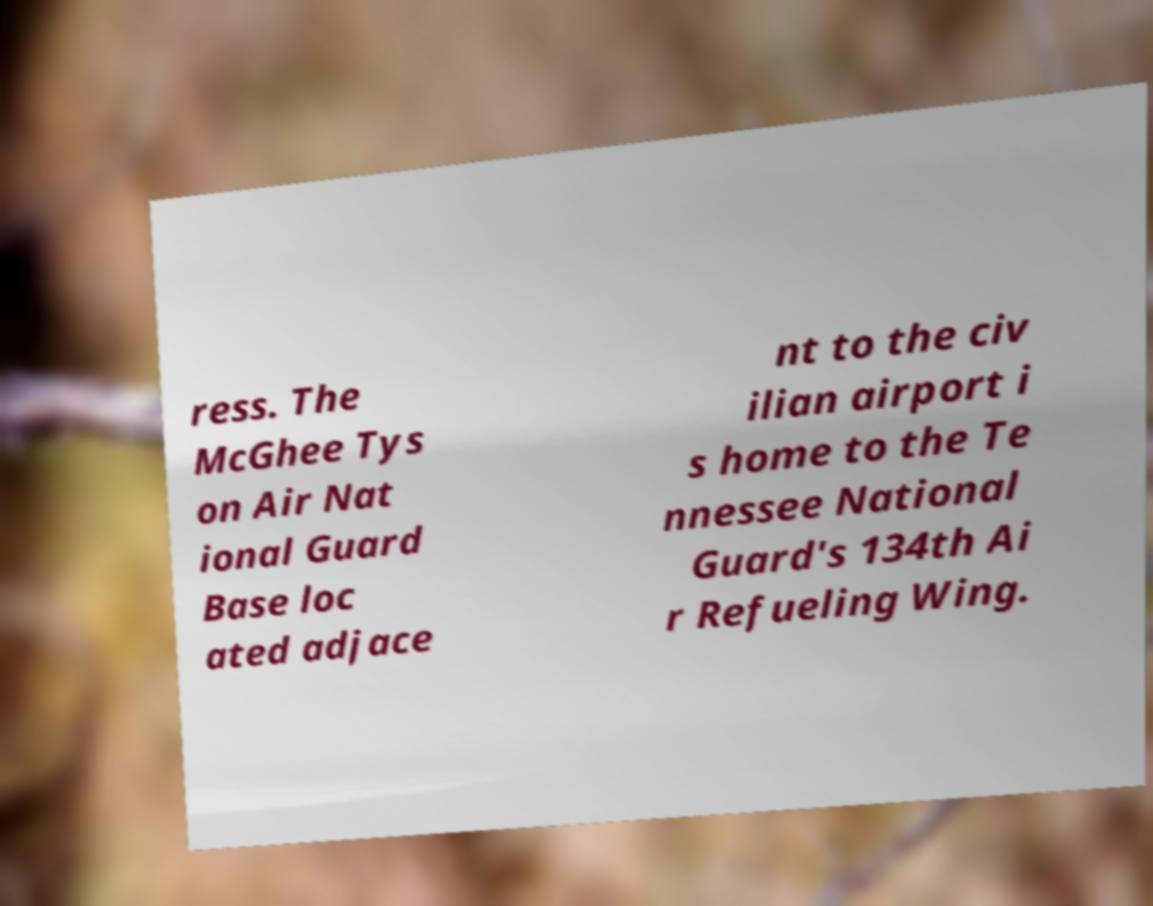Can you accurately transcribe the text from the provided image for me? ress. The McGhee Tys on Air Nat ional Guard Base loc ated adjace nt to the civ ilian airport i s home to the Te nnessee National Guard's 134th Ai r Refueling Wing. 